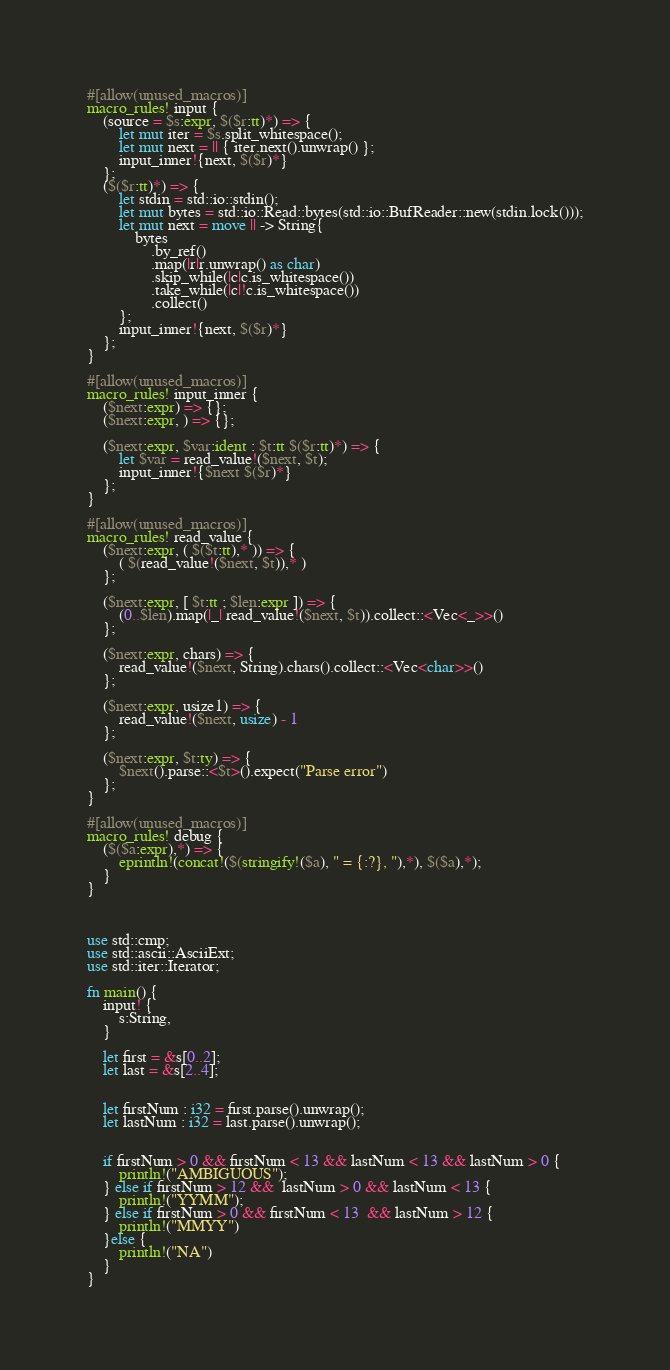Convert code to text. <code><loc_0><loc_0><loc_500><loc_500><_Rust_>#[allow(unused_macros)]
macro_rules! input {
    (source = $s:expr, $($r:tt)*) => {
        let mut iter = $s.split_whitespace();
        let mut next = || { iter.next().unwrap() };
        input_inner!{next, $($r)*}
    };
    ($($r:tt)*) => {
        let stdin = std::io::stdin();
        let mut bytes = std::io::Read::bytes(std::io::BufReader::new(stdin.lock()));
        let mut next = move || -> String{
            bytes
                .by_ref()
                .map(|r|r.unwrap() as char)
                .skip_while(|c|c.is_whitespace())
                .take_while(|c|!c.is_whitespace())
                .collect()
        };
        input_inner!{next, $($r)*}
    };
}

#[allow(unused_macros)]
macro_rules! input_inner {
    ($next:expr) => {};
    ($next:expr, ) => {};

    ($next:expr, $var:ident : $t:tt $($r:tt)*) => {
        let $var = read_value!($next, $t);
        input_inner!{$next $($r)*}
    };
}

#[allow(unused_macros)]
macro_rules! read_value {
    ($next:expr, ( $($t:tt),* )) => {
        ( $(read_value!($next, $t)),* )
    };

    ($next:expr, [ $t:tt ; $len:expr ]) => {
        (0..$len).map(|_| read_value!($next, $t)).collect::<Vec<_>>()
    };

    ($next:expr, chars) => {
        read_value!($next, String).chars().collect::<Vec<char>>()
    };

    ($next:expr, usize1) => {
        read_value!($next, usize) - 1
    };

    ($next:expr, $t:ty) => {
        $next().parse::<$t>().expect("Parse error")
    };
}

#[allow(unused_macros)]
macro_rules! debug {
    ($($a:expr),*) => {
        eprintln!(concat!($(stringify!($a), " = {:?}, "),*), $($a),*);
    }
}



use std::cmp;
use std::ascii::AsciiExt;
use std::iter::Iterator;

fn main() {
    input! {
        s:String,
    }

    let first = &s[0..2];
    let last = &s[2..4];


    let firstNum : i32 = first.parse().unwrap();
    let lastNum : i32 = last.parse().unwrap();


    if firstNum > 0 && firstNum < 13 && lastNum < 13 && lastNum > 0 {
        println!("AMBIGUOUS");
    } else if firstNum > 12 &&  lastNum > 0 && lastNum < 13 {
        println!("YYMM");
    } else if firstNum > 0 && firstNum < 13  && lastNum > 12 {
        println!("MMYY")
    }else {
        println!("NA")
    }
}

</code> 